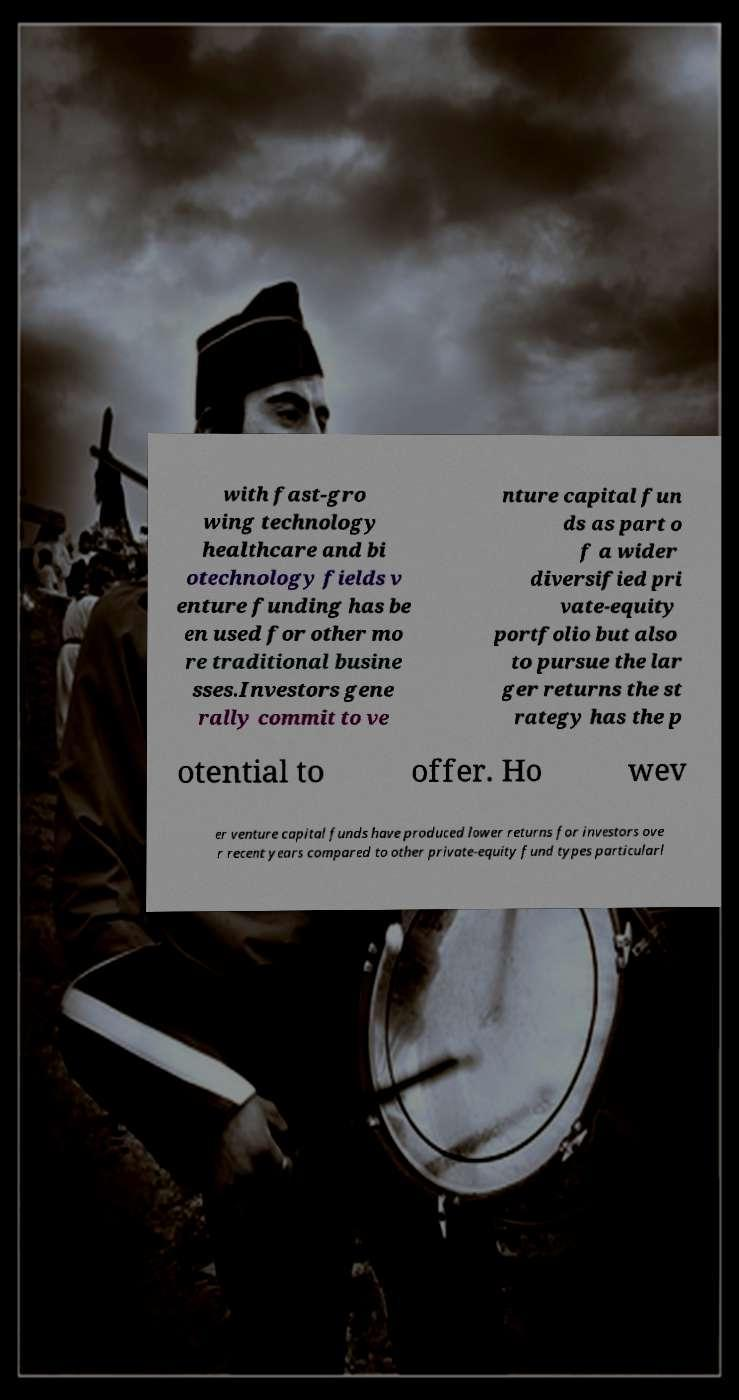Please read and relay the text visible in this image. What does it say? with fast-gro wing technology healthcare and bi otechnology fields v enture funding has be en used for other mo re traditional busine sses.Investors gene rally commit to ve nture capital fun ds as part o f a wider diversified pri vate-equity portfolio but also to pursue the lar ger returns the st rategy has the p otential to offer. Ho wev er venture capital funds have produced lower returns for investors ove r recent years compared to other private-equity fund types particularl 